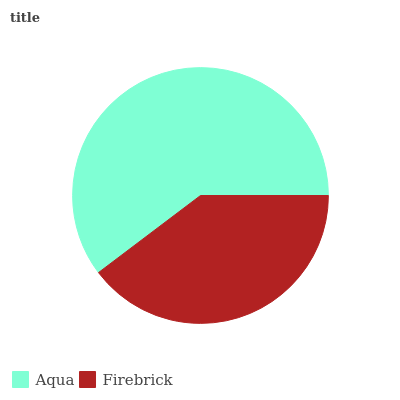Is Firebrick the minimum?
Answer yes or no. Yes. Is Aqua the maximum?
Answer yes or no. Yes. Is Firebrick the maximum?
Answer yes or no. No. Is Aqua greater than Firebrick?
Answer yes or no. Yes. Is Firebrick less than Aqua?
Answer yes or no. Yes. Is Firebrick greater than Aqua?
Answer yes or no. No. Is Aqua less than Firebrick?
Answer yes or no. No. Is Aqua the high median?
Answer yes or no. Yes. Is Firebrick the low median?
Answer yes or no. Yes. Is Firebrick the high median?
Answer yes or no. No. Is Aqua the low median?
Answer yes or no. No. 